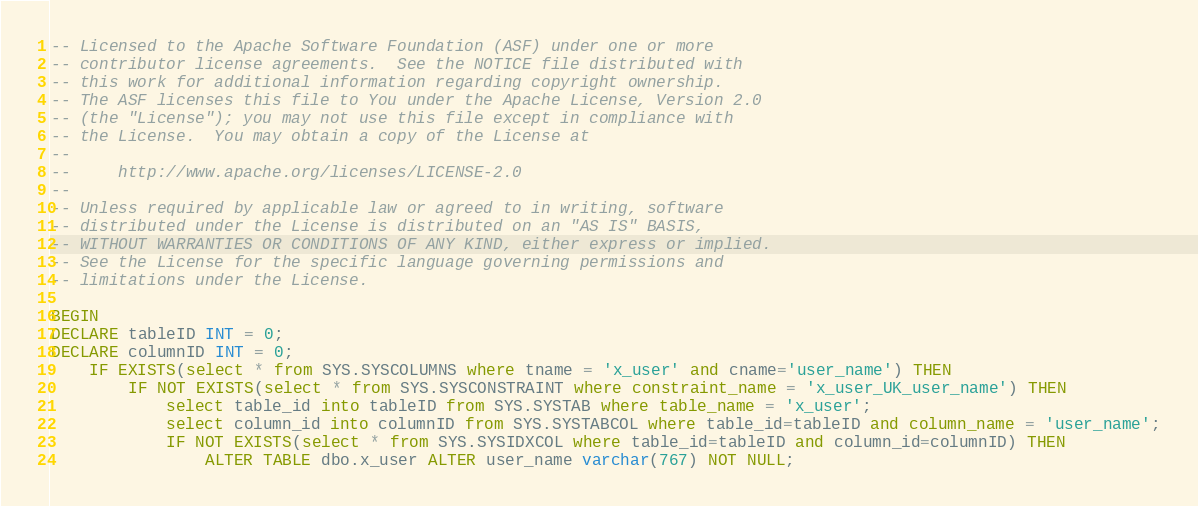<code> <loc_0><loc_0><loc_500><loc_500><_SQL_>-- Licensed to the Apache Software Foundation (ASF) under one or more
-- contributor license agreements.  See the NOTICE file distributed with
-- this work for additional information regarding copyright ownership.
-- The ASF licenses this file to You under the Apache License, Version 2.0
-- (the "License"); you may not use this file except in compliance with
-- the License.  You may obtain a copy of the License at
--
--     http://www.apache.org/licenses/LICENSE-2.0
--
-- Unless required by applicable law or agreed to in writing, software
-- distributed under the License is distributed on an "AS IS" BASIS,
-- WITHOUT WARRANTIES OR CONDITIONS OF ANY KIND, either express or implied.
-- See the License for the specific language governing permissions and
-- limitations under the License.

BEGIN
DECLARE tableID INT = 0;
DECLARE columnID INT = 0;
	IF EXISTS(select * from SYS.SYSCOLUMNS where tname = 'x_user' and cname='user_name') THEN
		IF NOT EXISTS(select * from SYS.SYSCONSTRAINT where constraint_name = 'x_user_UK_user_name') THEN
			select table_id into tableID from SYS.SYSTAB where table_name = 'x_user';
			select column_id into columnID from SYS.SYSTABCOL where table_id=tableID and column_name = 'user_name';
			IF NOT EXISTS(select * from SYS.SYSIDXCOL where table_id=tableID and column_id=columnID) THEN
				ALTER TABLE dbo.x_user ALTER user_name varchar(767) NOT NULL;</code> 